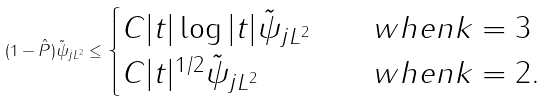<formula> <loc_0><loc_0><loc_500><loc_500>\| ( 1 - \hat { P } ) \tilde { \psi } _ { j } \| _ { L ^ { 2 } } \leq \begin{cases} C | t | \log | t | \| \tilde { \psi } _ { j } \| _ { L ^ { 2 } } \quad & w h e n k = 3 \\ C | t | ^ { 1 / 2 } \| \tilde { \psi } _ { j } \| _ { L ^ { 2 } } \quad & w h e n k = 2 . \end{cases}</formula> 